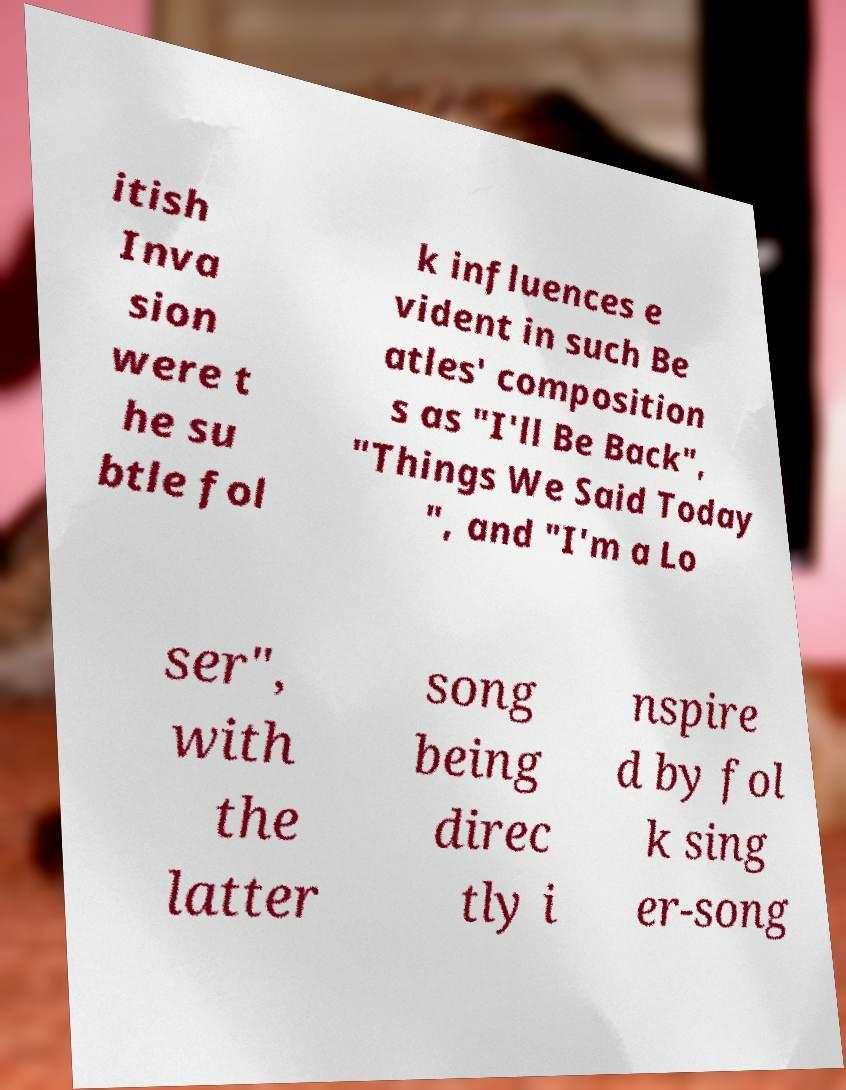What messages or text are displayed in this image? I need them in a readable, typed format. itish Inva sion were t he su btle fol k influences e vident in such Be atles' composition s as "I'll Be Back", "Things We Said Today ", and "I'm a Lo ser", with the latter song being direc tly i nspire d by fol k sing er-song 